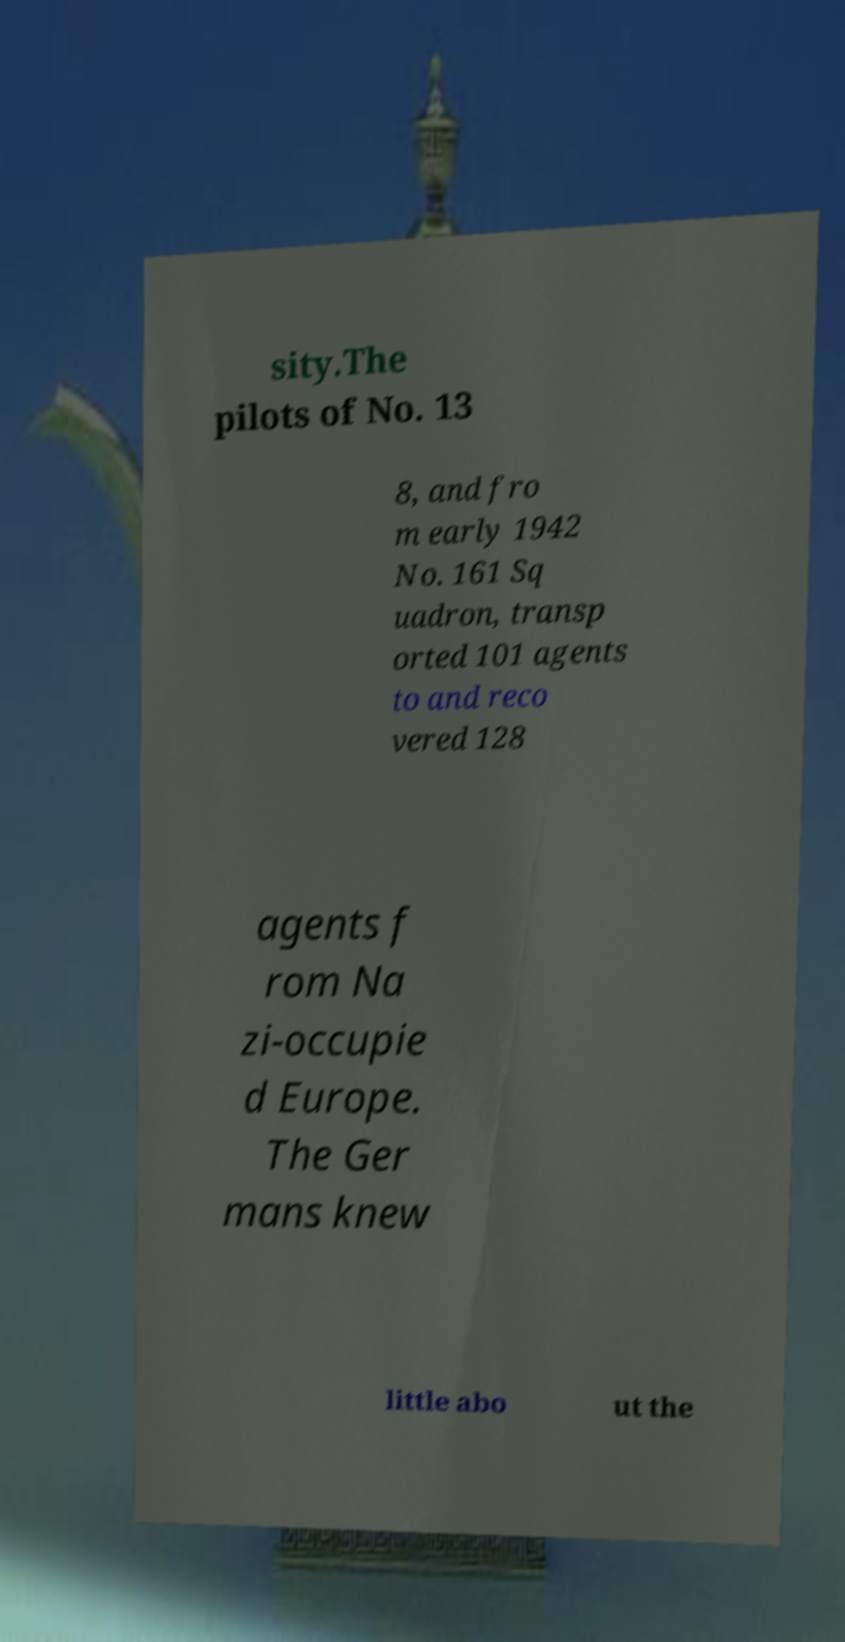Please read and relay the text visible in this image. What does it say? sity.The pilots of No. 13 8, and fro m early 1942 No. 161 Sq uadron, transp orted 101 agents to and reco vered 128 agents f rom Na zi-occupie d Europe. The Ger mans knew little abo ut the 